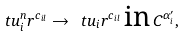Convert formula to latex. <formula><loc_0><loc_0><loc_500><loc_500>\ t u _ { i } ^ { n } r ^ { c _ { i l } } \rightarrow \ t u _ { i } r ^ { c _ { i l } } \, \text {in} \, C ^ { \alpha ^ { \prime } _ { i } } ,</formula> 